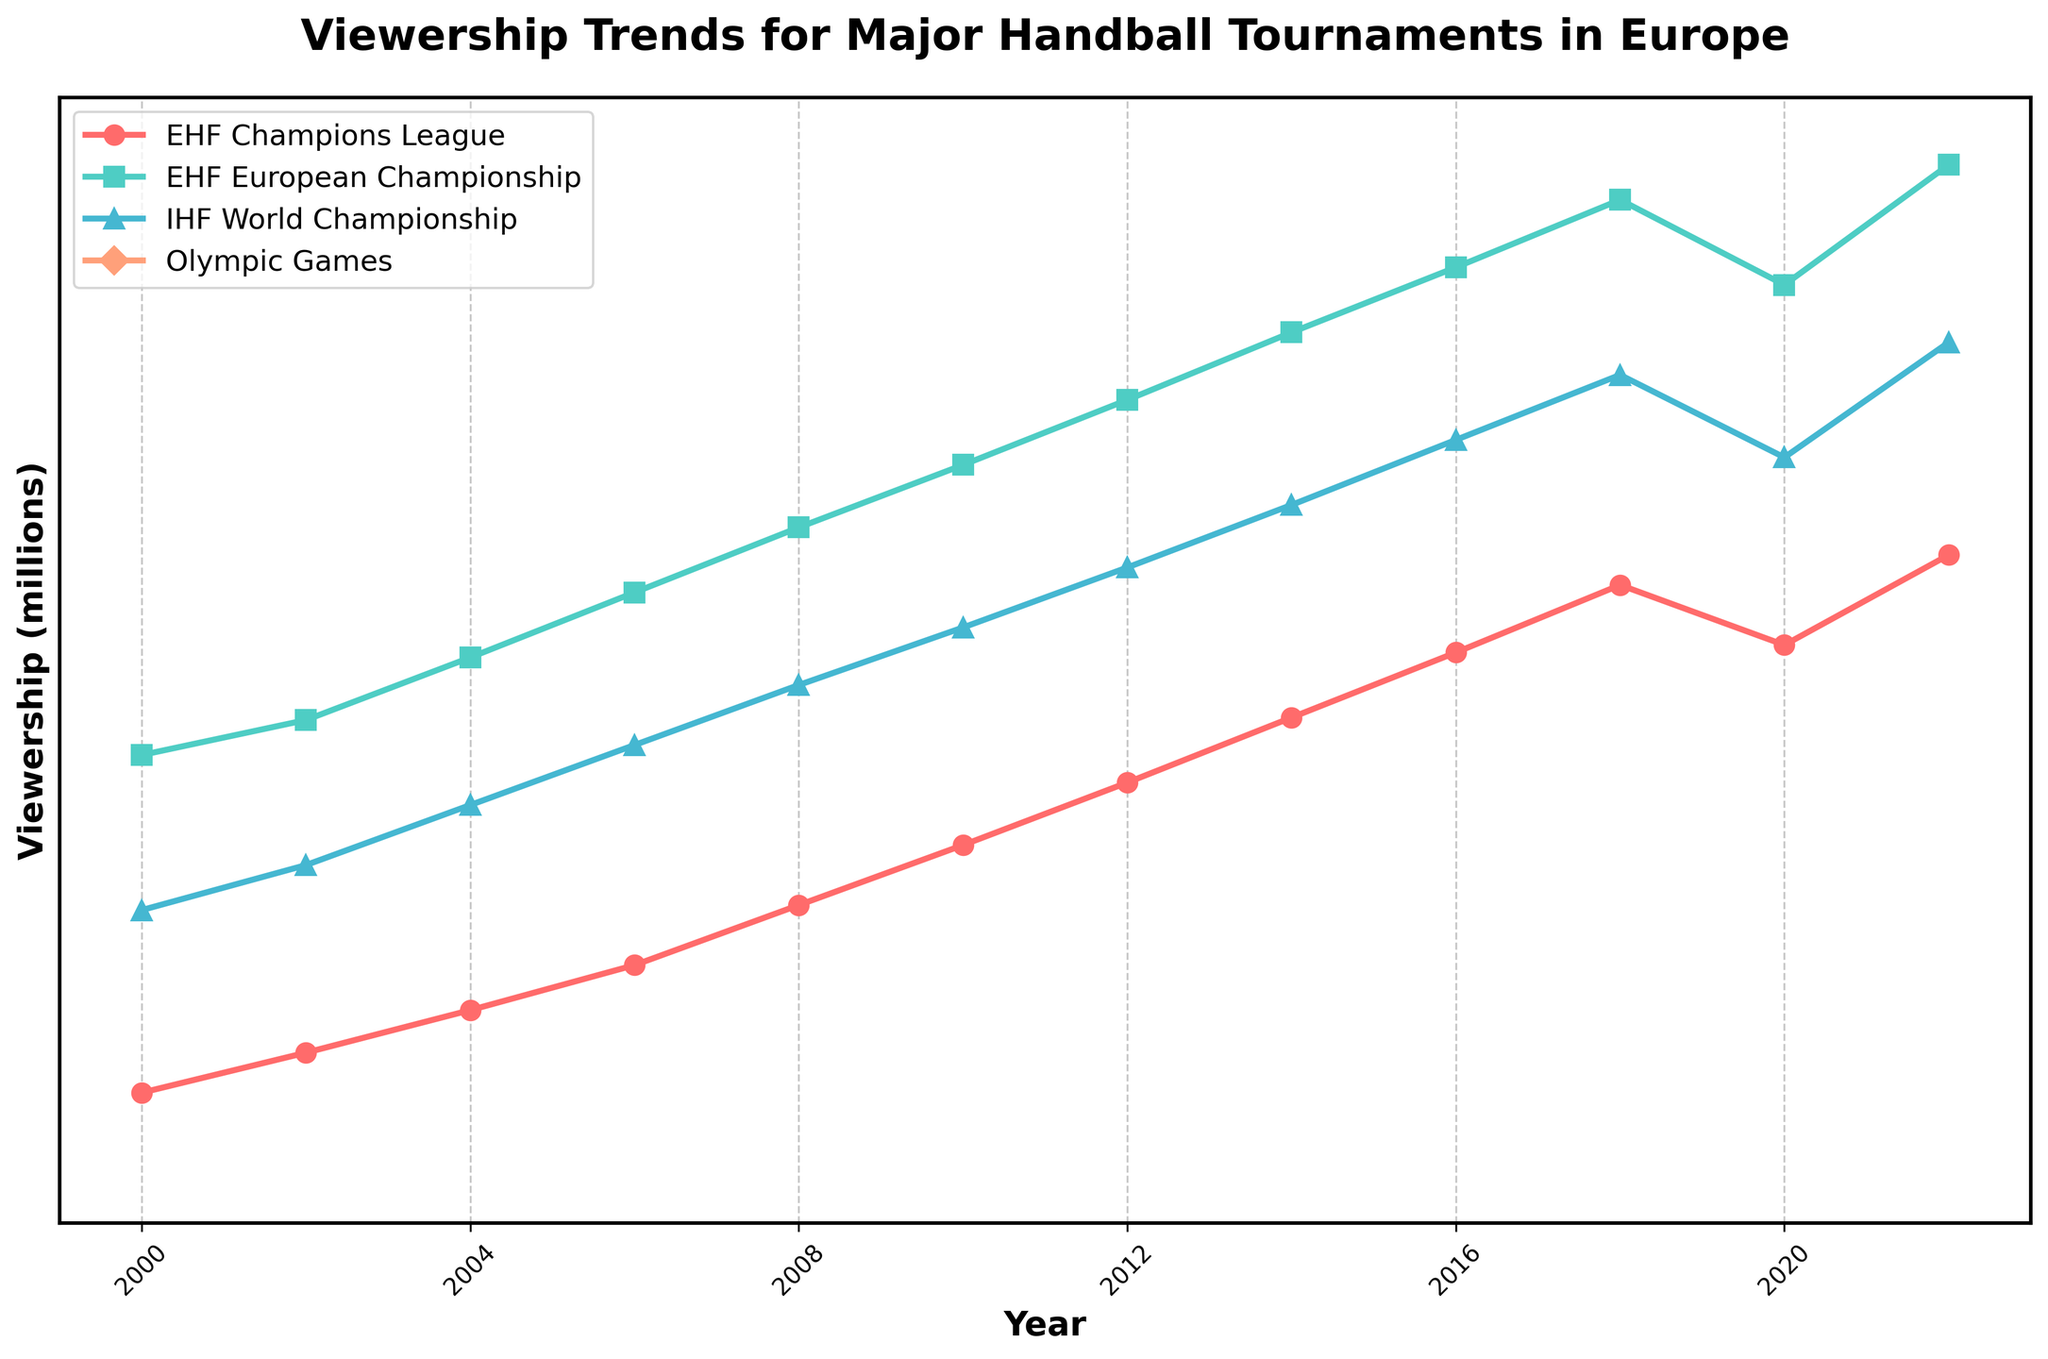What year had the highest viewership for the EHF European Championship? The highest point on the EHF European Championship line is at 52.3 million. This corresponds to the year 2022 shown on the x-axis.
Answer: 2022 Has the viewership of the EHF Champions League always increased over time? Following the line for the EHF Champions League, we see a constant increase from 2000 to 2018. However, it slightly decreases in 2020 before rising again in 2022.
Answer: No What is the difference in viewership between the IHF World Championship and EHF European Championship in 2018? In 2018, the viewership for the IHF World Championship is 43.9 million, and for the EHF European Championship, it's 50.9 million. The difference is 50.9 - 43.9 = 7 million.
Answer: 7 million Compare the viewership of the Olympic Games in 2012 and the viewership of the EHF European Championship in 2018. Which one is higher? In 2012, the Olympic Games had a viewership of 39.5 million. In 2018, the EHF European Championship had a viewership of 50.9 million. Comparing the two, 50.9 million is greater than 39.5 million.
Answer: EHF European Championship What are the visual differences between the lines representing the EHF European Championship and the Olympic Games? The EHF European Championship line is a solid cyan line with square markers, while the Olympic Games line is a solid salmon line with diamond markers.
Answer: Different colors and markers During which year did the EHF Champions League first surpass 30 million in viewership? The EHF Champions League line surpasses 30 million viewership in the year 2014.
Answer: 2014 What is the combined viewership of all tournaments in 2008? Adding the viewerships: EHF Champions League (22.7), EHF European Championship (37.8), IHF World Championship (31.5), Olympic Games (36.9) results in 22.7 + 37.8 + 31.5 + 36.9 = 128.9 million.
Answer: 128.9 million Which tournament had the least growth in viewership from 2000 to 2022? Calculate each tournament's growth: EHF Champions League (36.7 - 15.2 = 21.5), EHF European Championship (52.3 - 28.7 = 23.6), IHF World Championship (45.2 - 22.5 = 22.7), Olympic Games, only with two years of data. The EHF Champions League had the least growth of 21.5 million.
Answer: EHF Champions League When looking at the EHF European Championship, identify the two-year periods when the viewership increased by at least 2 million. Observing the increments: 2000-2002 (1.4), 2002-2004 (2.5), 2004-2006 (2.6), 2006-2008 (2.6), 2008-2010 (2.5), 2010-2012 (2.6), 2012-2014 (2.7), 2014-2016 (2.6), 2016-2018 (2.7). The periods are: 2002-2004, 2004-2006, 2006-2008, 2008-2010, 2010-2012, 2012-2014, 2014-2016, 2016-2018.
Answer: 2002-2004, 2004-2006, 2006-2008, 2008-2010, 2010-2012, 2012-2014, 2014-2016, 2016-2018 